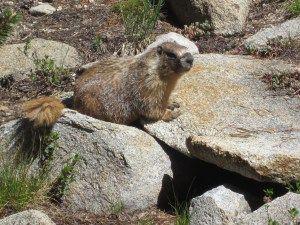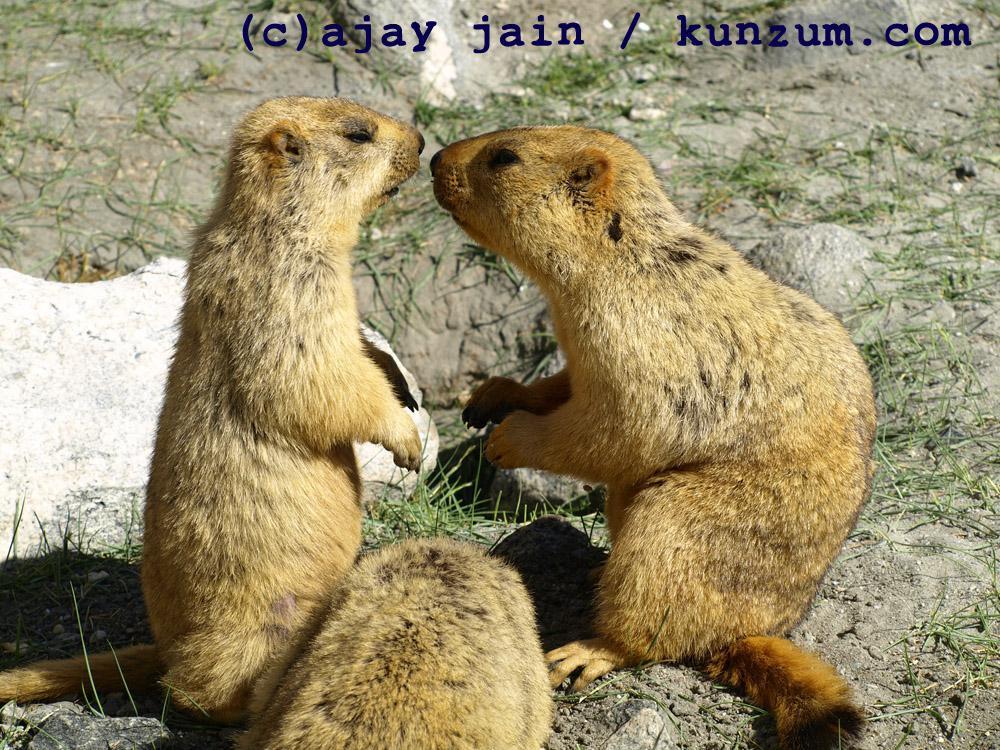The first image is the image on the left, the second image is the image on the right. Analyze the images presented: Is the assertion "There is exactly two rodents." valid? Answer yes or no. No. 